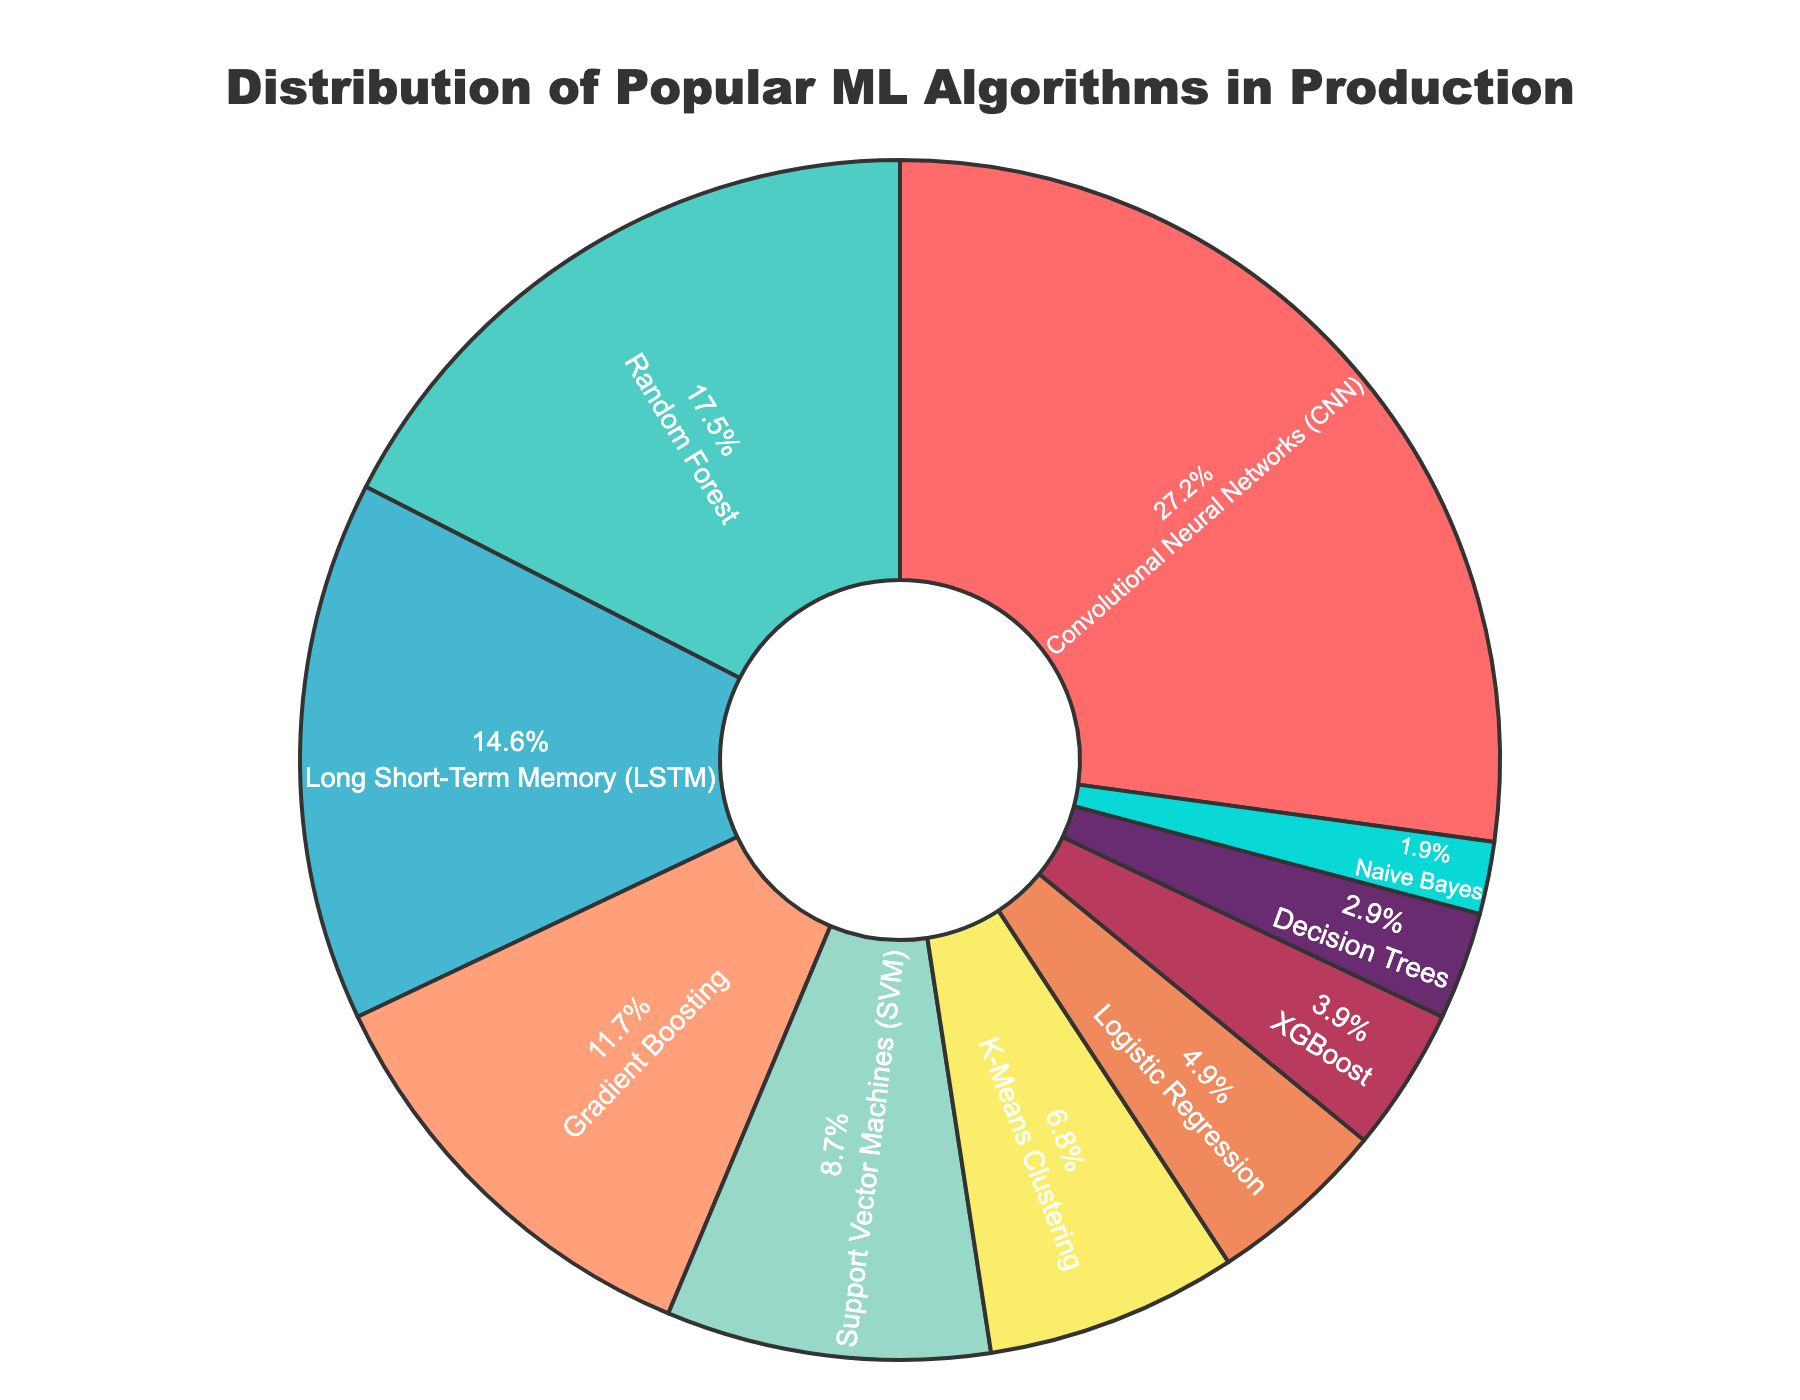What algorithm has the highest percentage usage in production environments? The pie chart shows the distribution with 'Convolutional Neural Networks (CNN)' having the largest section at 28%.
Answer: Convolutional Neural Networks (CNN) Which two algorithms combined account for more than 40% of the usage? By adding percentages, CNNs are 28% and Random Forests are 18%, totaling 46%, which is more than 40%.
Answer: CNN and Random Forest Is the percentage of usage for K-Means Clustering higher or lower than that for Support Vector Machines (SVM)? The pie chart shows K-Means Clustering at 7% and SVM at 9%. Thus, K-Means Clustering is lower.
Answer: Lower What is the combined percentage usage of Gradient Boosting, XGBoost, and Naive Bayes? Sum their percentages: 12% (Gradient Boosting) + 4% (XGBoost) + 2% (Naive Bayes) equals 18%.
Answer: 18% Which algorithm has the smallest usage in production environments, and what is its percentage? The slice corresponding to 'Naive Bayes' is the smallest at 2%.
Answer: Naive Bayes, 2% How much larger is the usage percentage of CNN compared to Logistic Regression? CNN's usage is 28%, and Logistic Regression's is 5%. The difference is 28% - 5% = 23%.
Answer: 23% What is the visual attribute used to distinguish different algorithms in the pie chart? The sections are differentiated by different colors.
Answer: Colors If you combine the usage of all algorithms except CNN and Random Forest, what percentage do you get? Add all other percentages: LSTM(15%) + Gradient Boosting(12%) + SVM(9%) + K-Means(7%) + Logistic Regression(5%) + XGBoost(4%) + Decision Trees(3%) + Naive Bayes(2%) = 57%.
Answer: 57% Are there more algorithms used in production with a percentage less than or equal to 10% or more than 10%? Count the algorithms: ≤ 10% are six (SVM, K-Means, Logistic Regression, XGBoost, Decision Trees, Naive Bayes); > 10% are four (CNN, Random Forest, LSTM, Gradient Boosting). There are more with ≤ 10%.
Answer: ≤ 10% What's the difference in usage between the least used algorithm and the most used algorithm? Difference between Naive Bayes (2%) and CNN (28%) is 28% - 2% = 26%.
Answer: 26% 